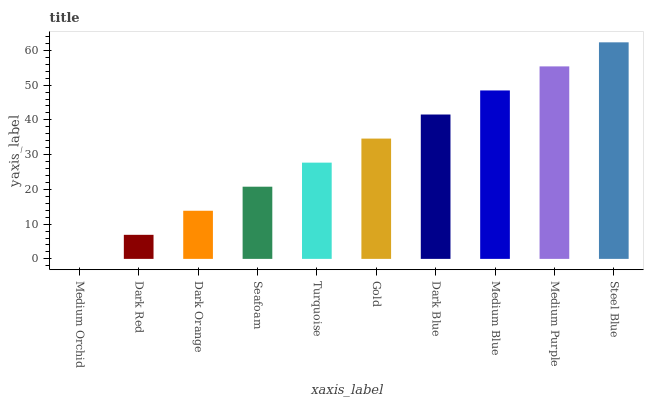Is Medium Orchid the minimum?
Answer yes or no. Yes. Is Steel Blue the maximum?
Answer yes or no. Yes. Is Dark Red the minimum?
Answer yes or no. No. Is Dark Red the maximum?
Answer yes or no. No. Is Dark Red greater than Medium Orchid?
Answer yes or no. Yes. Is Medium Orchid less than Dark Red?
Answer yes or no. Yes. Is Medium Orchid greater than Dark Red?
Answer yes or no. No. Is Dark Red less than Medium Orchid?
Answer yes or no. No. Is Gold the high median?
Answer yes or no. Yes. Is Turquoise the low median?
Answer yes or no. Yes. Is Medium Purple the high median?
Answer yes or no. No. Is Medium Orchid the low median?
Answer yes or no. No. 